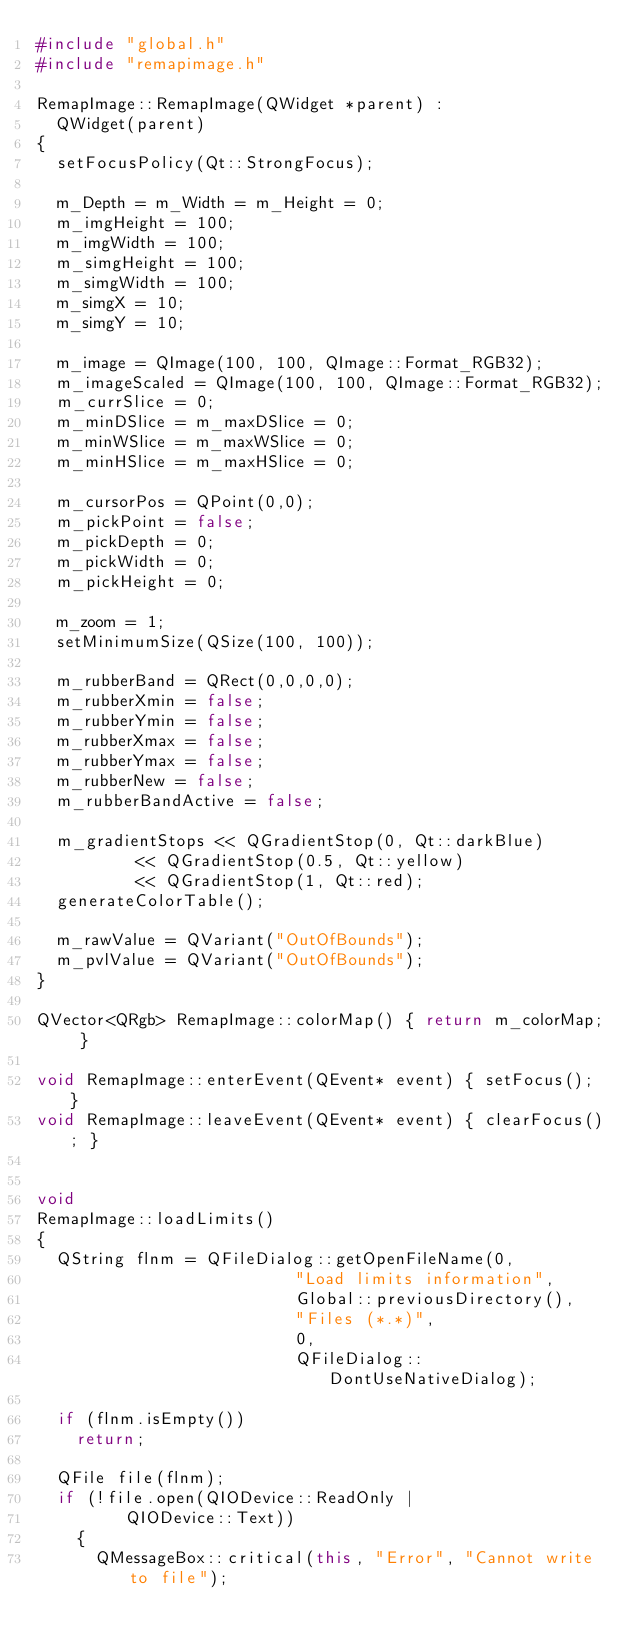<code> <loc_0><loc_0><loc_500><loc_500><_C++_>#include "global.h"
#include "remapimage.h"

RemapImage::RemapImage(QWidget *parent) :
  QWidget(parent)
{
  setFocusPolicy(Qt::StrongFocus);

  m_Depth = m_Width = m_Height = 0;
  m_imgHeight = 100;
  m_imgWidth = 100;
  m_simgHeight = 100;
  m_simgWidth = 100;
  m_simgX = 10;
  m_simgY = 10;

  m_image = QImage(100, 100, QImage::Format_RGB32);
  m_imageScaled = QImage(100, 100, QImage::Format_RGB32);
  m_currSlice = 0;
  m_minDSlice = m_maxDSlice = 0;
  m_minWSlice = m_maxWSlice = 0;
  m_minHSlice = m_maxHSlice = 0;

  m_cursorPos = QPoint(0,0);
  m_pickPoint = false;
  m_pickDepth = 0;
  m_pickWidth = 0;
  m_pickHeight = 0;

  m_zoom = 1;
  setMinimumSize(QSize(100, 100));

  m_rubberBand = QRect(0,0,0,0);
  m_rubberXmin = false;
  m_rubberYmin = false;
  m_rubberXmax = false;
  m_rubberYmax = false;
  m_rubberNew = false;
  m_rubberBandActive = false;

  m_gradientStops << QGradientStop(0, Qt::darkBlue)
		  << QGradientStop(0.5, Qt::yellow)
		  << QGradientStop(1, Qt::red);
  generateColorTable();

  m_rawValue = QVariant("OutOfBounds");
  m_pvlValue = QVariant("OutOfBounds");
}

QVector<QRgb> RemapImage::colorMap() { return m_colorMap; }

void RemapImage::enterEvent(QEvent* event) { setFocus(); }
void RemapImage::leaveEvent(QEvent* event) { clearFocus(); }


void
RemapImage::loadLimits()
{
  QString flnm = QFileDialog::getOpenFileName(0,
					      "Load limits information",
					      Global::previousDirectory(),
					      "Files (*.*)",
					      0,
					      QFileDialog::DontUseNativeDialog);

  if (flnm.isEmpty())
    return;

  QFile file(flnm);
  if (!file.open(QIODevice::ReadOnly |
		 QIODevice::Text))
    {
      QMessageBox::critical(this, "Error", "Cannot write to file");</code> 